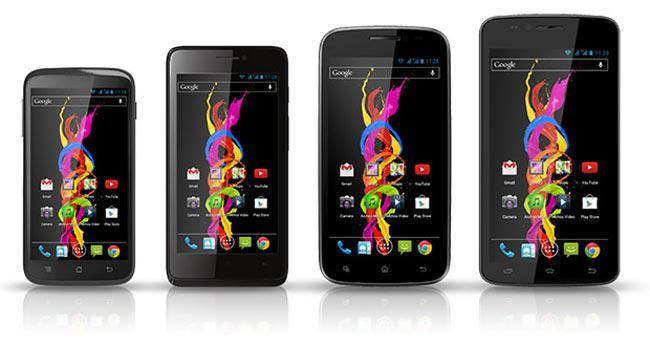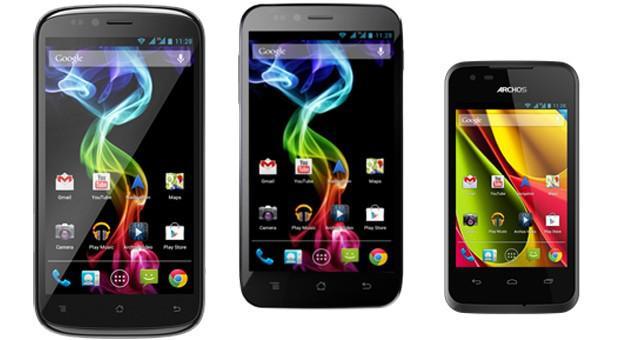The first image is the image on the left, the second image is the image on the right. Given the left and right images, does the statement "One of the phones has physical keys." hold true? Answer yes or no. No. The first image is the image on the left, the second image is the image on the right. For the images shown, is this caption "One image shows three screened devices in a row, and each image includes rainbow colors in a curving ribbon shape on at least one screen." true? Answer yes or no. Yes. 